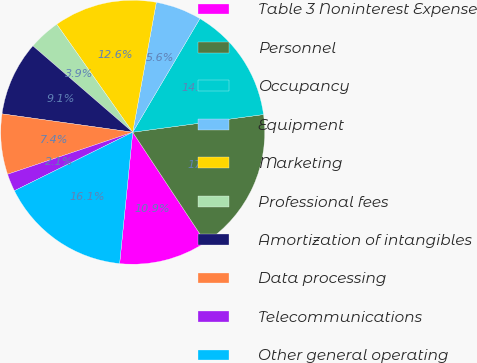Convert chart. <chart><loc_0><loc_0><loc_500><loc_500><pie_chart><fcel>Table 3 Noninterest Expense<fcel>Personnel<fcel>Occupancy<fcel>Equipment<fcel>Marketing<fcel>Professional fees<fcel>Amortization of intangibles<fcel>Data processing<fcel>Telecommunications<fcel>Other general operating<nl><fcel>10.87%<fcel>17.85%<fcel>14.36%<fcel>5.64%<fcel>12.62%<fcel>3.89%<fcel>9.13%<fcel>7.38%<fcel>2.15%<fcel>16.11%<nl></chart> 